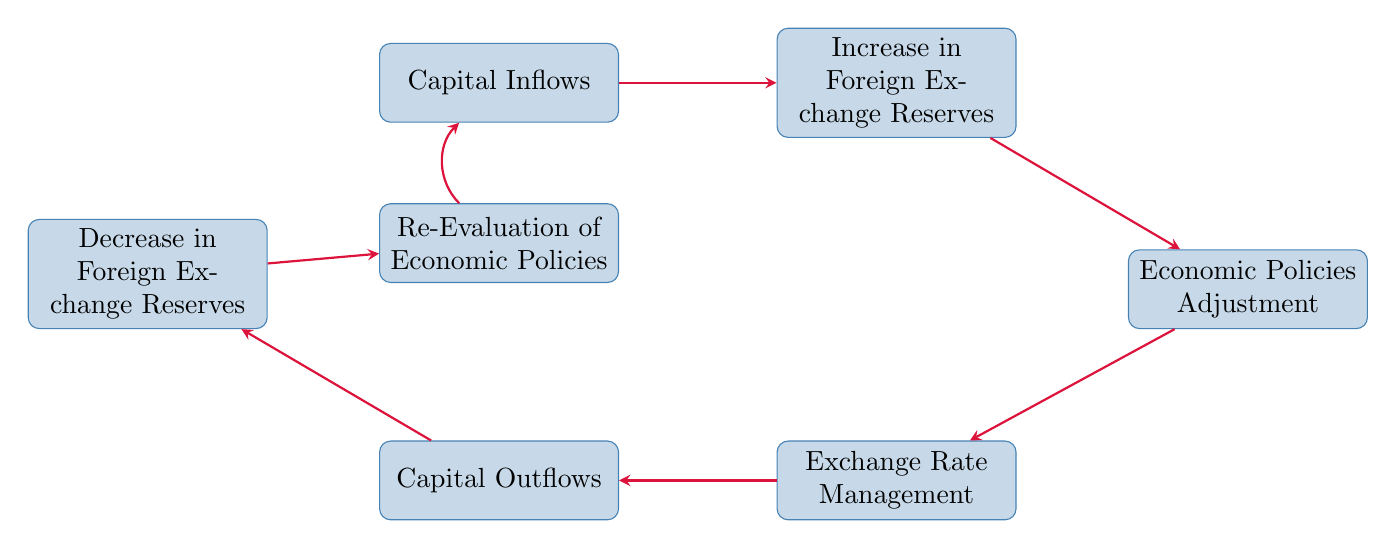What is the first step in the flow chart? The first step shown in the flow chart is "Capital Inflows," which signifies the entry of foreign investments and borrowings into the country.
Answer: Capital Inflows How many nodes are in the flow chart? By counting each distinct step represented in the flow chart, we find there are a total of seven nodes.
Answer: Seven What does the "Increase in Foreign Exchange Reserves" lead to? "Increase in Foreign Exchange Reserves" directly leads to "Economic Policies Adjustment," as indicated by the arrow flowing from it in the diagram.
Answer: Economic Policies Adjustment What follows "Decrease in Foreign Exchange Reserves"? Following "Decrease in Foreign Exchange Reserves," the next step is "Re-Evaluation of Economic Policies," according to the flow direction in the diagram.
Answer: Re-Evaluation of Economic Policies What is the relationship between "Exchange Rate Management" and "Capital Outflows"? "Exchange Rate Management" influences or leads to "Capital Outflows" as the next step in the sequence, meaning it directly addresses actions related to capital moving out of the country.
Answer: Capital Outflows How does "Re-Evaluation of Economic Policies" connect back in the flow? "Re-Evaluation of Economic Policies" connects back to "Capital Inflows," creating a cyclical relationship between these two nodes, as shown by the arrow.
Answer: Capital Inflows What type of economic action is "Economic Policies Adjustment"? "Economic Policies Adjustment" refers to central bank actions in adapting monetary policy, such as changing interest rates, impacting liquidity and economic stability.
Answer: Central bank actions What results from "Capital Outflows"? "Capital Outflows" results in "Decrease in Foreign Exchange Reserves," indicating that as money leaves the country, the central bank's foreign currency holdings diminish.
Answer: Decrease in Foreign Exchange Reserves 